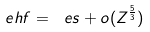Convert formula to latex. <formula><loc_0><loc_0><loc_500><loc_500>\ e h f = \ e s + o ( Z ^ { \frac { 5 } { 3 } } )</formula> 